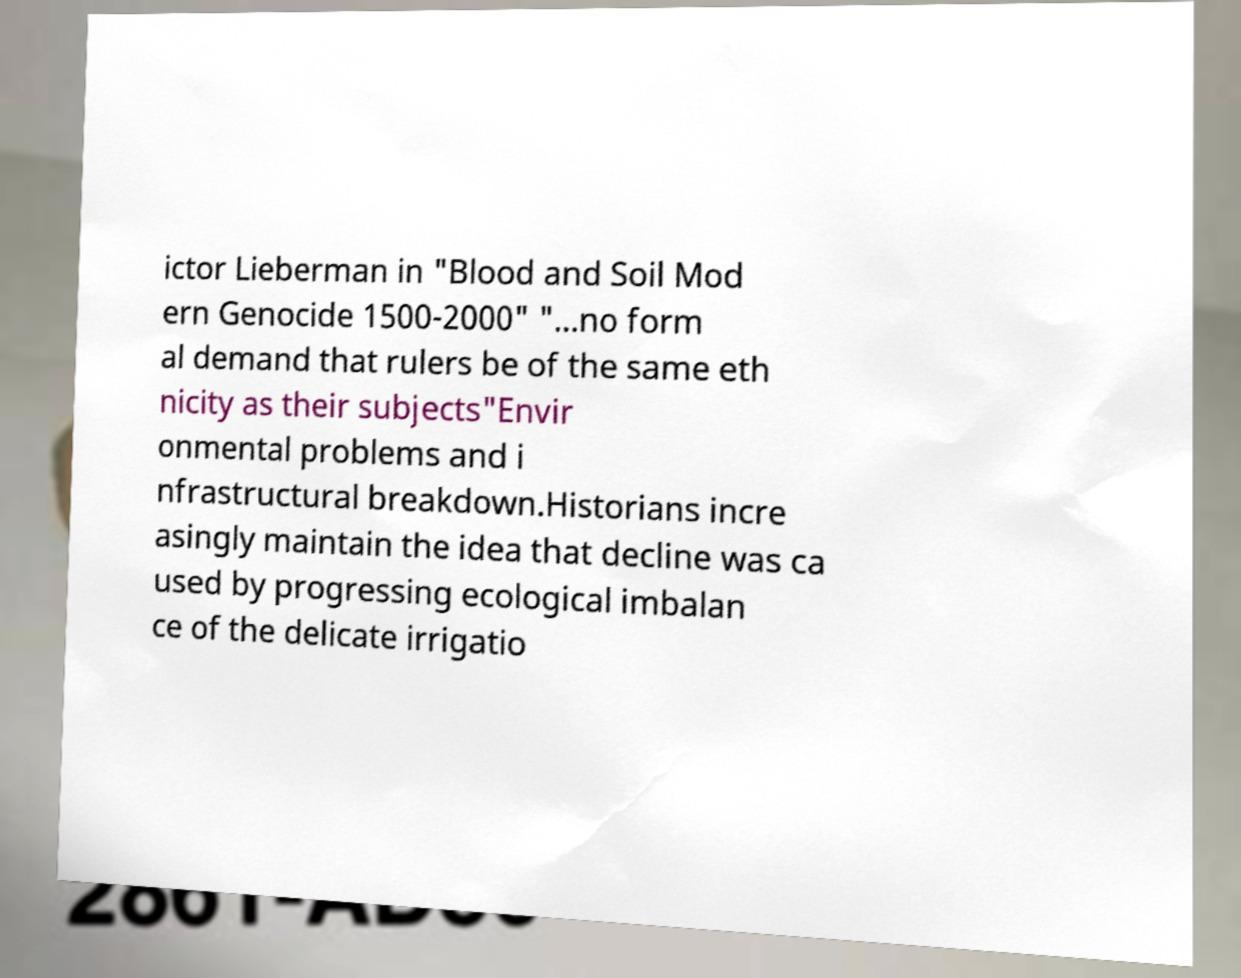Can you read and provide the text displayed in the image?This photo seems to have some interesting text. Can you extract and type it out for me? ictor Lieberman in "Blood and Soil Mod ern Genocide 1500-2000" "...no form al demand that rulers be of the same eth nicity as their subjects"Envir onmental problems and i nfrastructural breakdown.Historians incre asingly maintain the idea that decline was ca used by progressing ecological imbalan ce of the delicate irrigatio 